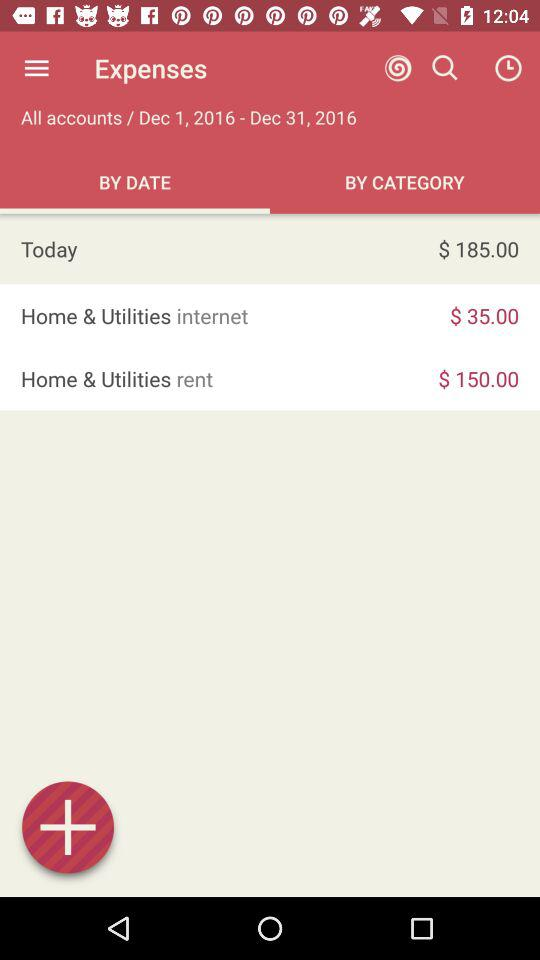How much is the income?
When the provided information is insufficient, respond with <no answer>. <no answer> 